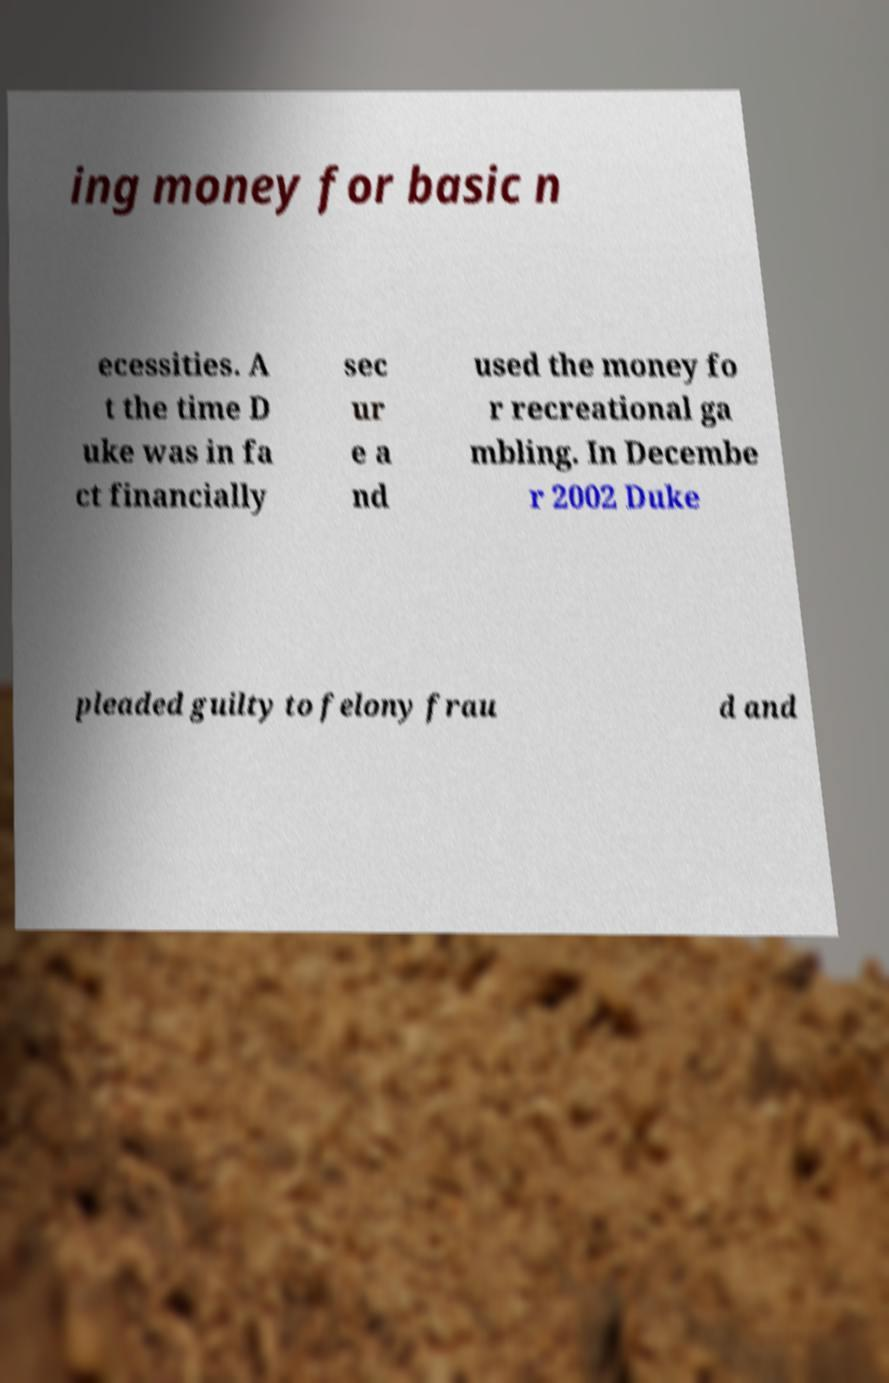Could you assist in decoding the text presented in this image and type it out clearly? ing money for basic n ecessities. A t the time D uke was in fa ct financially sec ur e a nd used the money fo r recreational ga mbling. In Decembe r 2002 Duke pleaded guilty to felony frau d and 